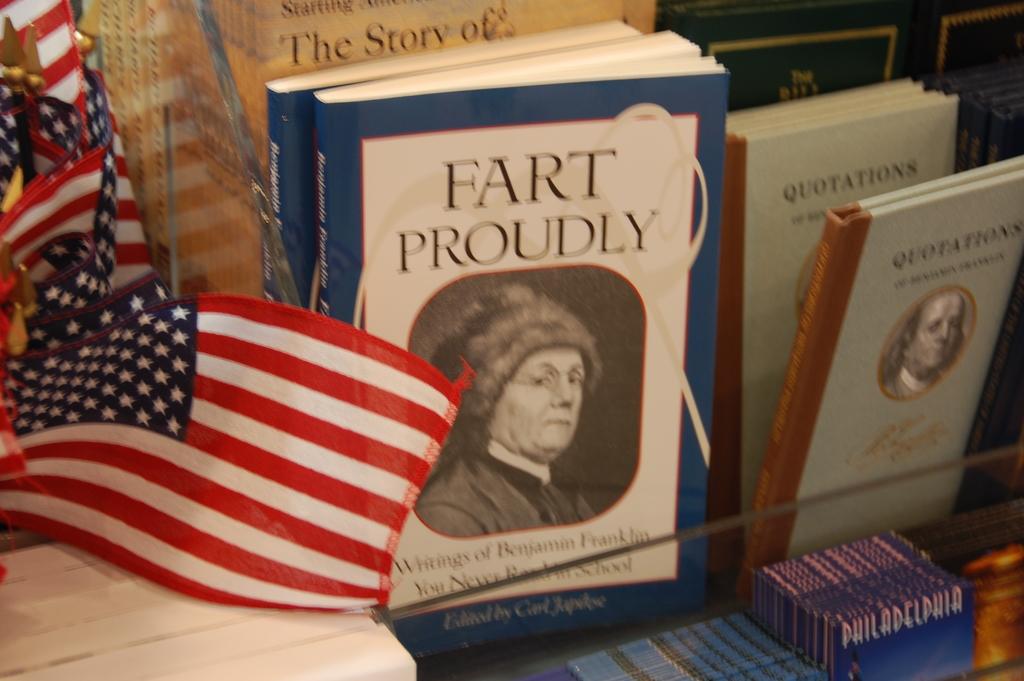What should you do proudly?
Offer a very short reply. Fart. Fart proudly contains who's writings?
Provide a succinct answer. Benjamin franklin. 